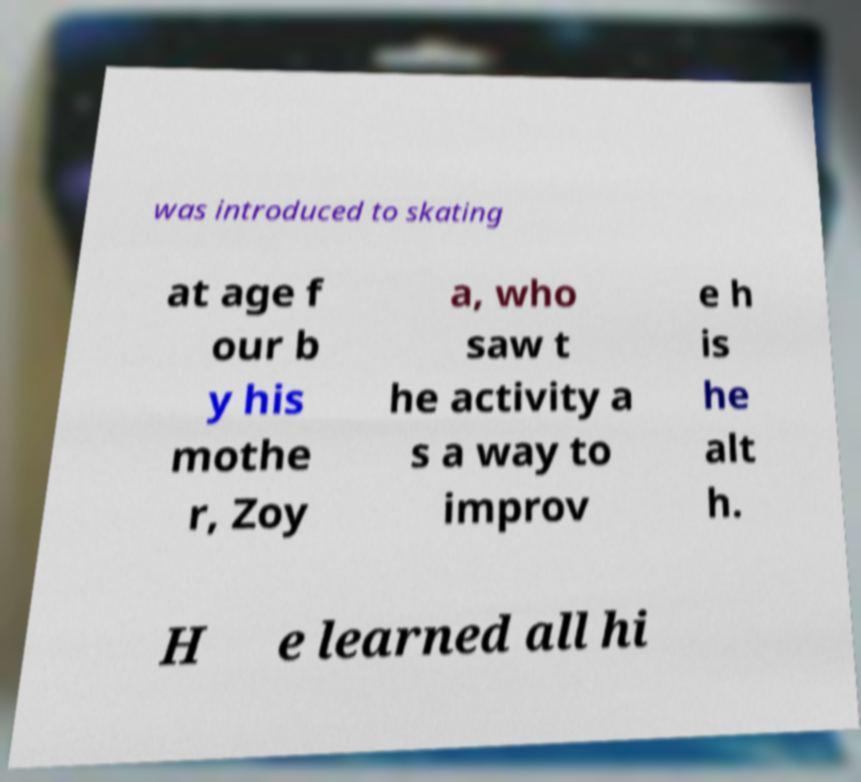Can you read and provide the text displayed in the image?This photo seems to have some interesting text. Can you extract and type it out for me? was introduced to skating at age f our b y his mothe r, Zoy a, who saw t he activity a s a way to improv e h is he alt h. H e learned all hi 